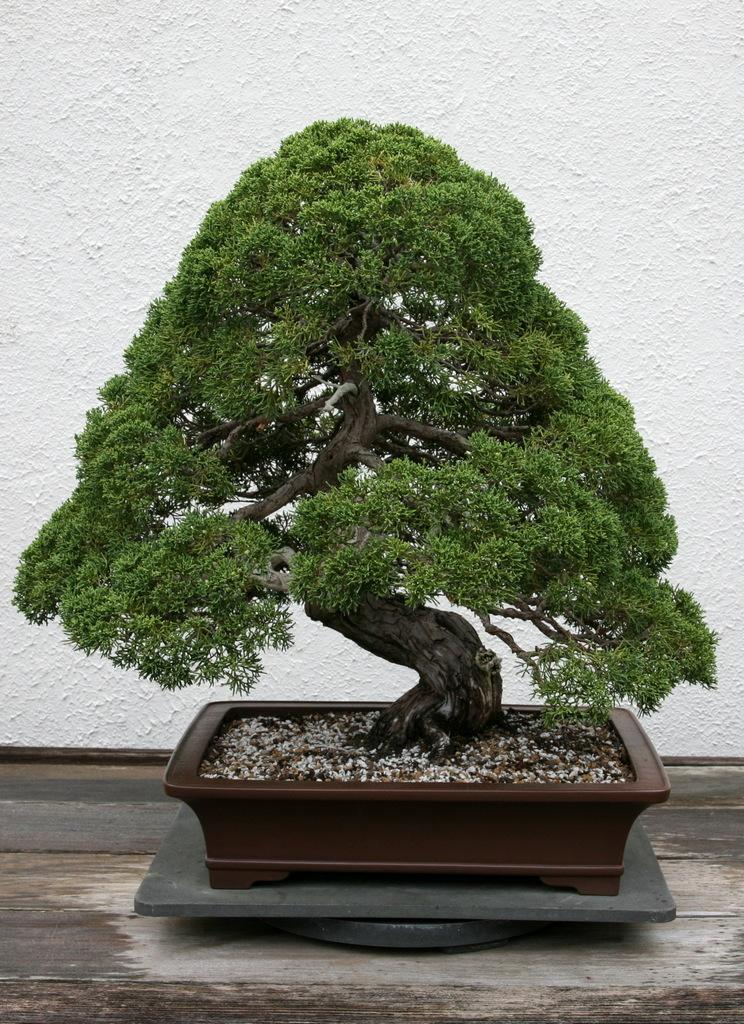What type of plant can be seen in the image? There is a tree in the image. What is visible in the background of the image? There is a white wall in the background of the image. What type of riddle is the tree trying to solve in the image? There is no indication in the image that the tree is trying to solve a riddle, as trees do not have the ability to solve riddles. 